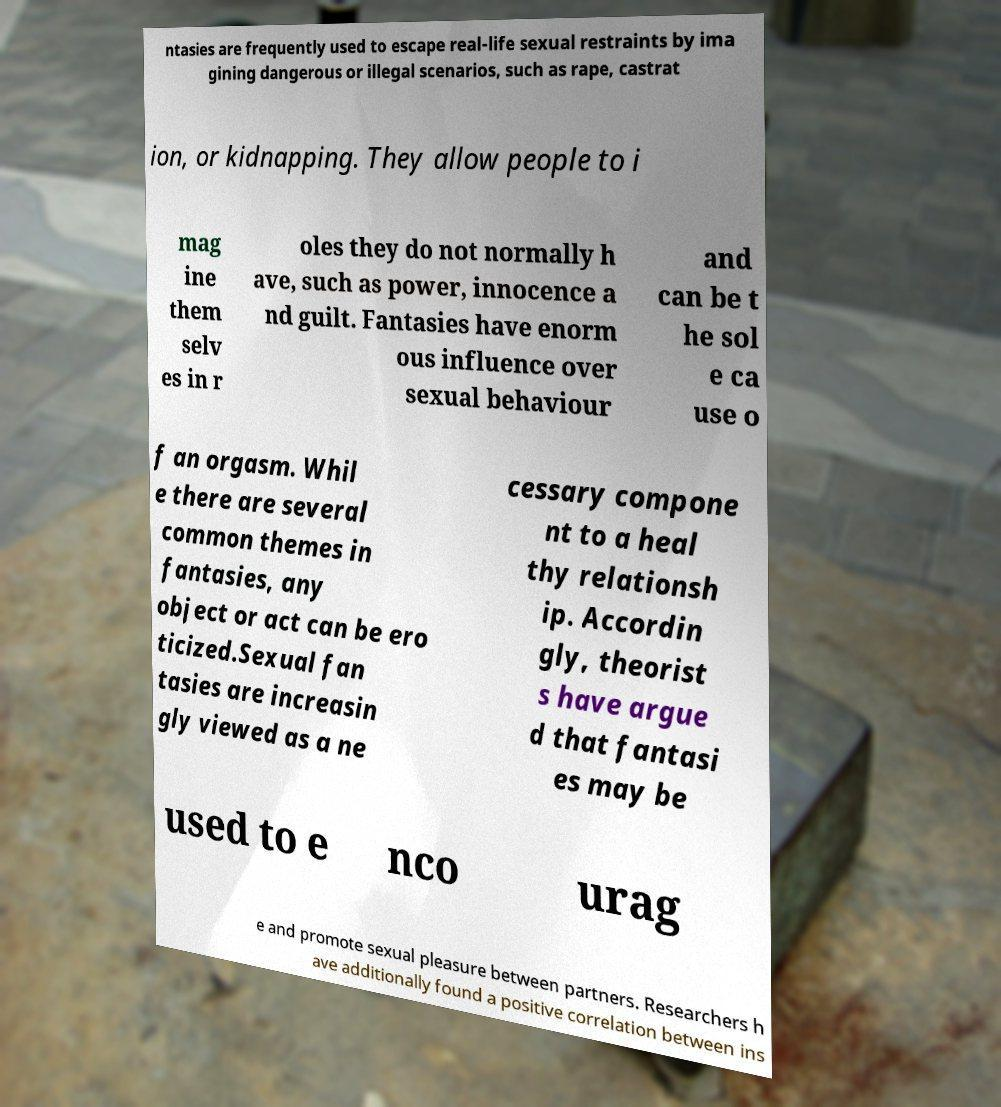Could you assist in decoding the text presented in this image and type it out clearly? ntasies are frequently used to escape real-life sexual restraints by ima gining dangerous or illegal scenarios, such as rape, castrat ion, or kidnapping. They allow people to i mag ine them selv es in r oles they do not normally h ave, such as power, innocence a nd guilt. Fantasies have enorm ous influence over sexual behaviour and can be t he sol e ca use o f an orgasm. Whil e there are several common themes in fantasies, any object or act can be ero ticized.Sexual fan tasies are increasin gly viewed as a ne cessary compone nt to a heal thy relationsh ip. Accordin gly, theorist s have argue d that fantasi es may be used to e nco urag e and promote sexual pleasure between partners. Researchers h ave additionally found a positive correlation between ins 